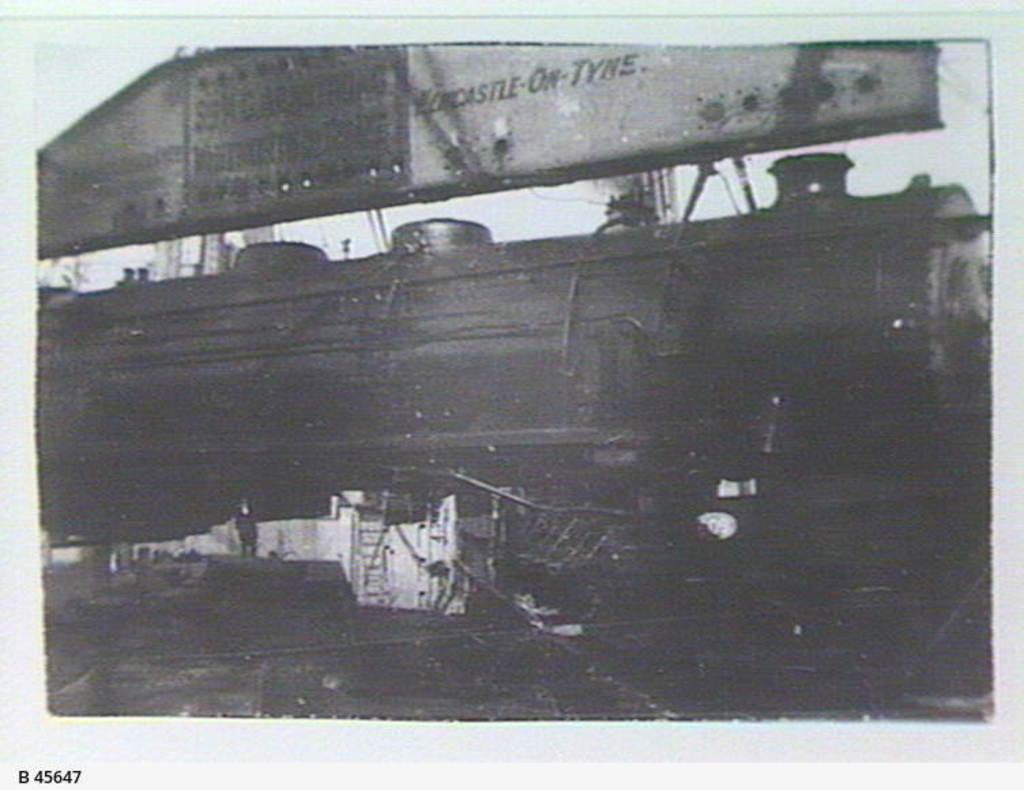Please provide a concise description of this image. In this image, we can see a poster with some images. We can also see some text on the bottom left corner. 